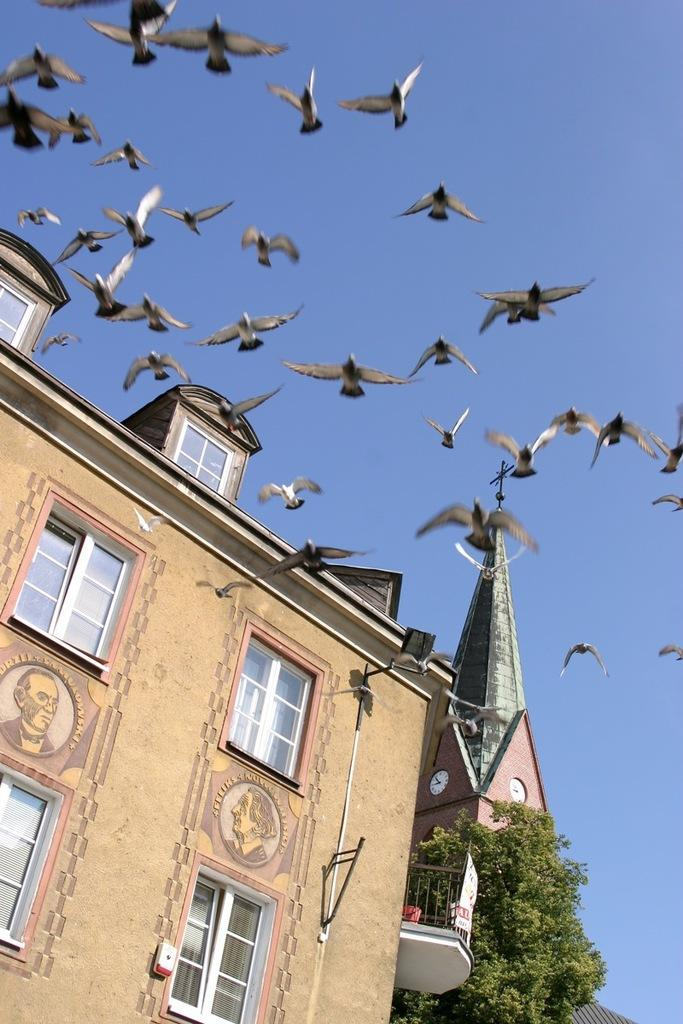What type of structures are present in the image? There are buildings in the image. What feature can be seen on the buildings? There are windows in the image. What type of animals are visible in the image? There are birds in the image. What type of vegetation is present in the image? There are trees in the image. What is visible at the top of the image? The sky is visible at the top of the image. How many eyes can be seen on the writer in the image? There is no writer present in the image, so it is not possible to determine the number of eyes. What type of division is depicted in the image? There is no division or separation shown in the image; it features buildings, windows, birds, trees, and the sky. 